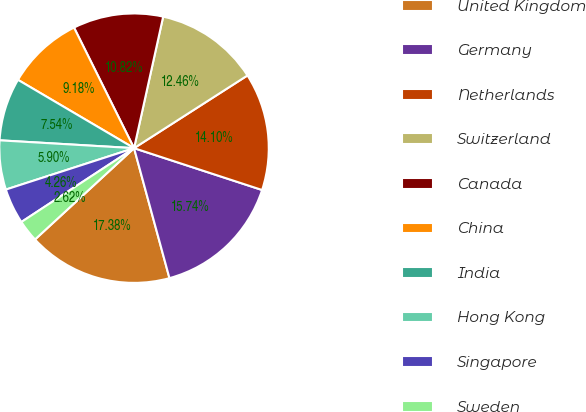Convert chart. <chart><loc_0><loc_0><loc_500><loc_500><pie_chart><fcel>United Kingdom<fcel>Germany<fcel>Netherlands<fcel>Switzerland<fcel>Canada<fcel>China<fcel>India<fcel>Hong Kong<fcel>Singapore<fcel>Sweden<nl><fcel>17.38%<fcel>15.74%<fcel>14.1%<fcel>12.46%<fcel>10.82%<fcel>9.18%<fcel>7.54%<fcel>5.9%<fcel>4.26%<fcel>2.62%<nl></chart> 